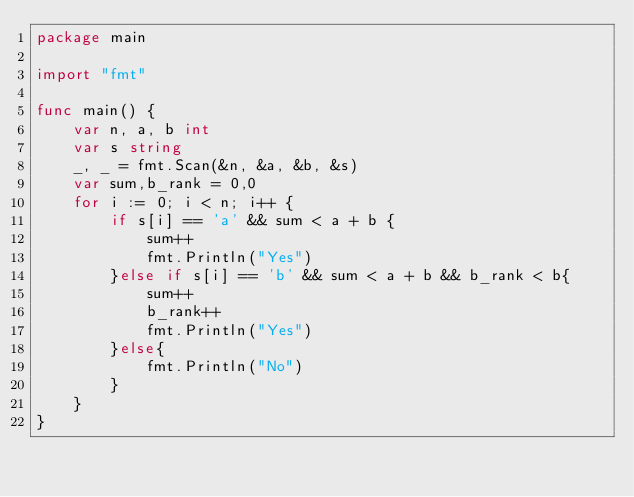Convert code to text. <code><loc_0><loc_0><loc_500><loc_500><_Go_>package main

import "fmt"

func main() {
	var n, a, b int
	var s string
	_, _ = fmt.Scan(&n, &a, &b, &s)
	var sum,b_rank = 0,0
	for i := 0; i < n; i++ {
		if s[i] == 'a' && sum < a + b {
			sum++
			fmt.Println("Yes")
		}else if s[i] == 'b' && sum < a + b && b_rank < b{
			sum++
			b_rank++
			fmt.Println("Yes")
		}else{
			fmt.Println("No")
		}
	}
}
</code> 